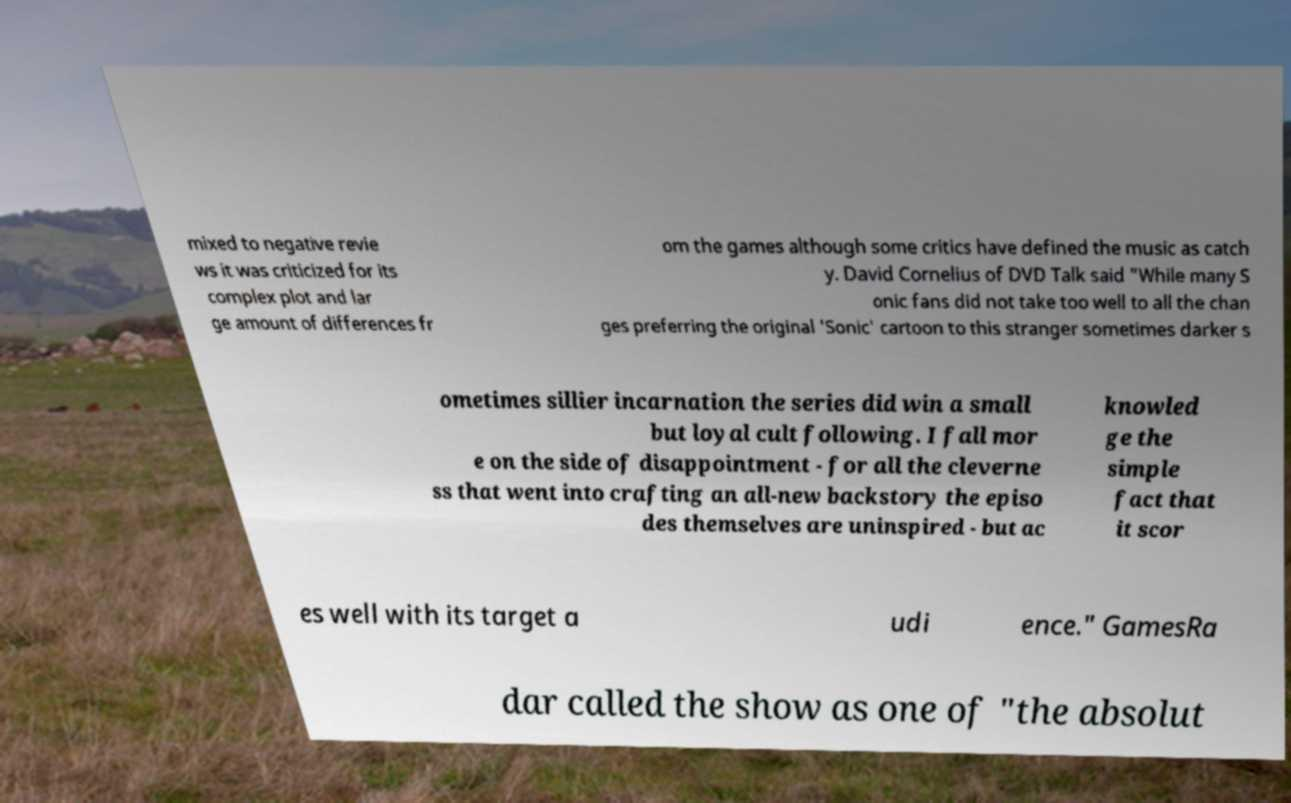Please identify and transcribe the text found in this image. mixed to negative revie ws it was criticized for its complex plot and lar ge amount of differences fr om the games although some critics have defined the music as catch y. David Cornelius of DVD Talk said "While many S onic fans did not take too well to all the chan ges preferring the original 'Sonic' cartoon to this stranger sometimes darker s ometimes sillier incarnation the series did win a small but loyal cult following. I fall mor e on the side of disappointment - for all the cleverne ss that went into crafting an all-new backstory the episo des themselves are uninspired - but ac knowled ge the simple fact that it scor es well with its target a udi ence." GamesRa dar called the show as one of "the absolut 